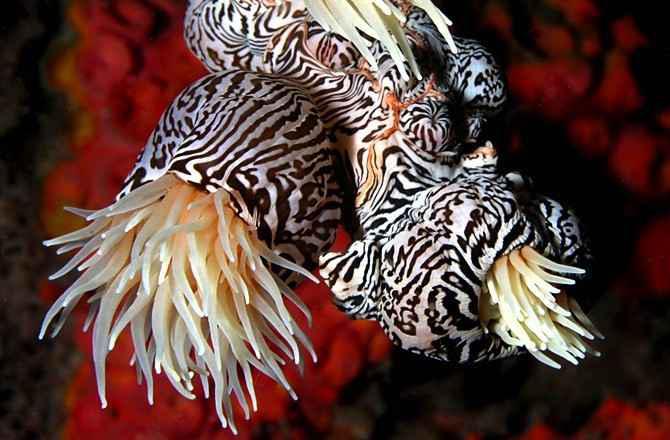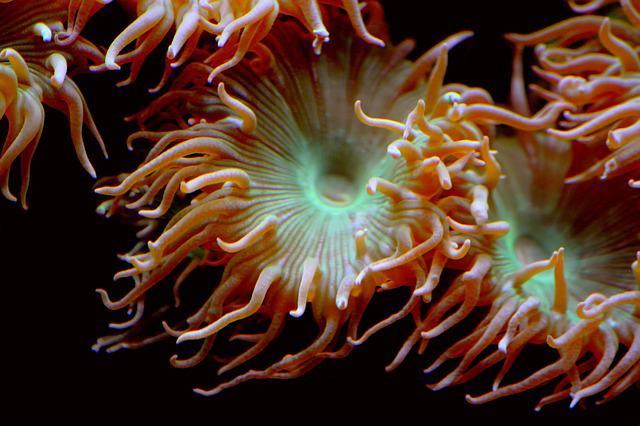The first image is the image on the left, the second image is the image on the right. Analyze the images presented: Is the assertion "The creature in the image on the left has black and white markings." valid? Answer yes or no. Yes. 